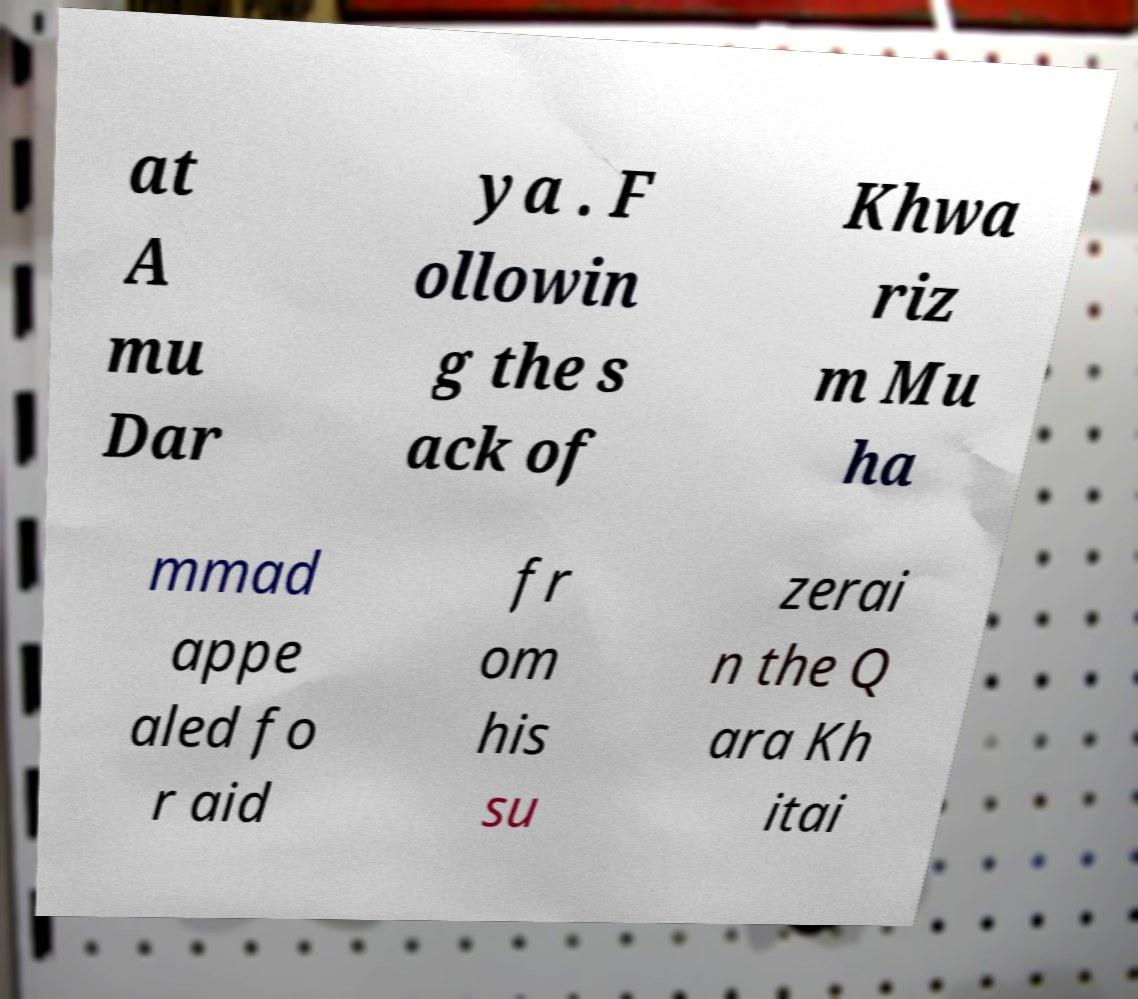For documentation purposes, I need the text within this image transcribed. Could you provide that? at A mu Dar ya . F ollowin g the s ack of Khwa riz m Mu ha mmad appe aled fo r aid fr om his su zerai n the Q ara Kh itai 